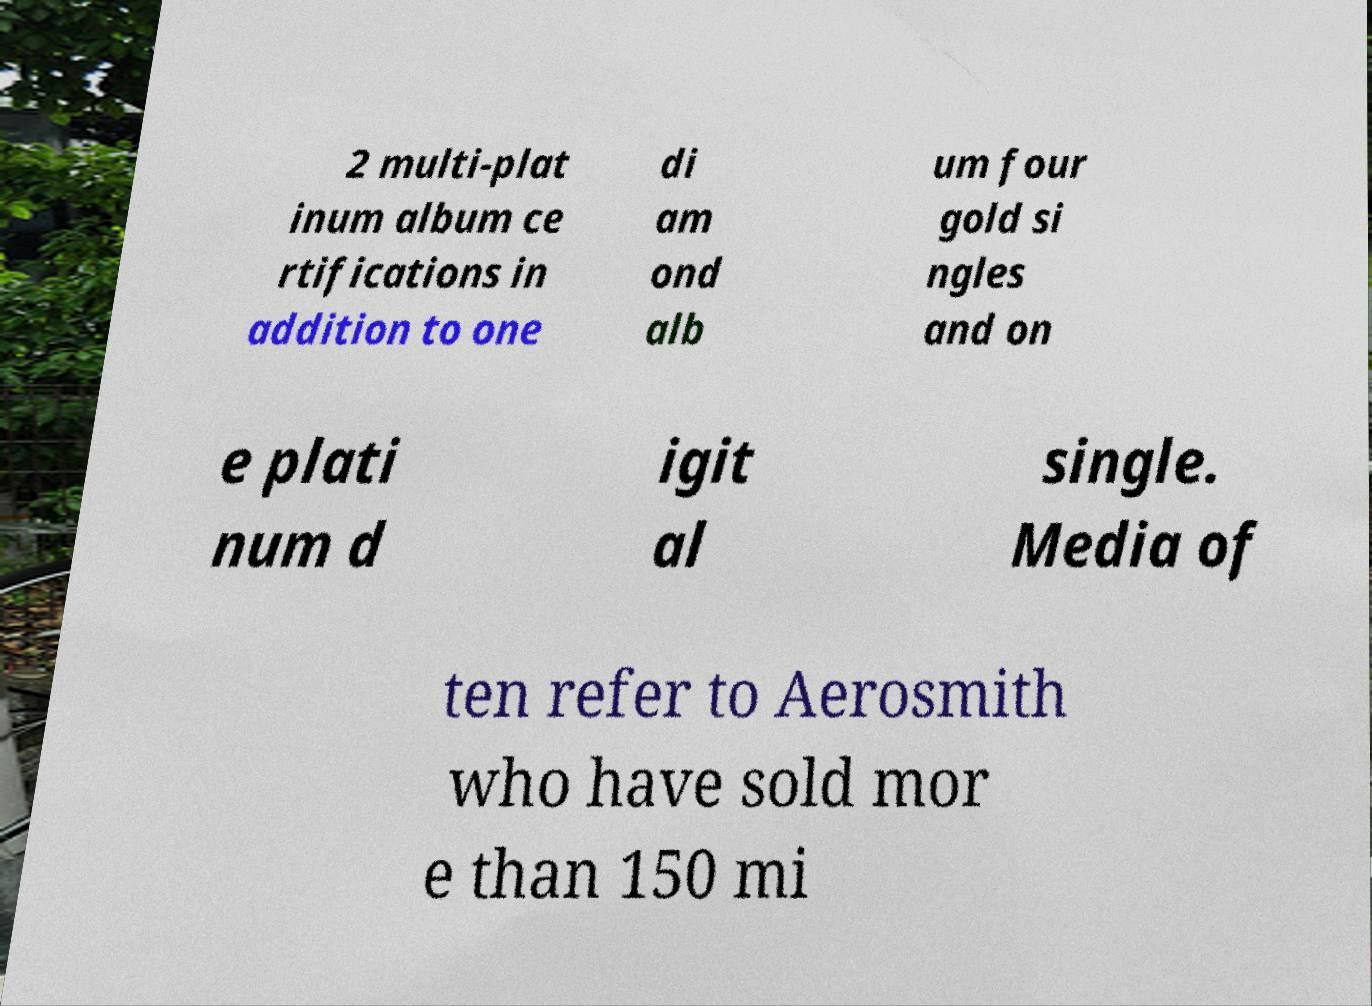Could you assist in decoding the text presented in this image and type it out clearly? 2 multi-plat inum album ce rtifications in addition to one di am ond alb um four gold si ngles and on e plati num d igit al single. Media of ten refer to Aerosmith who have sold mor e than 150 mi 